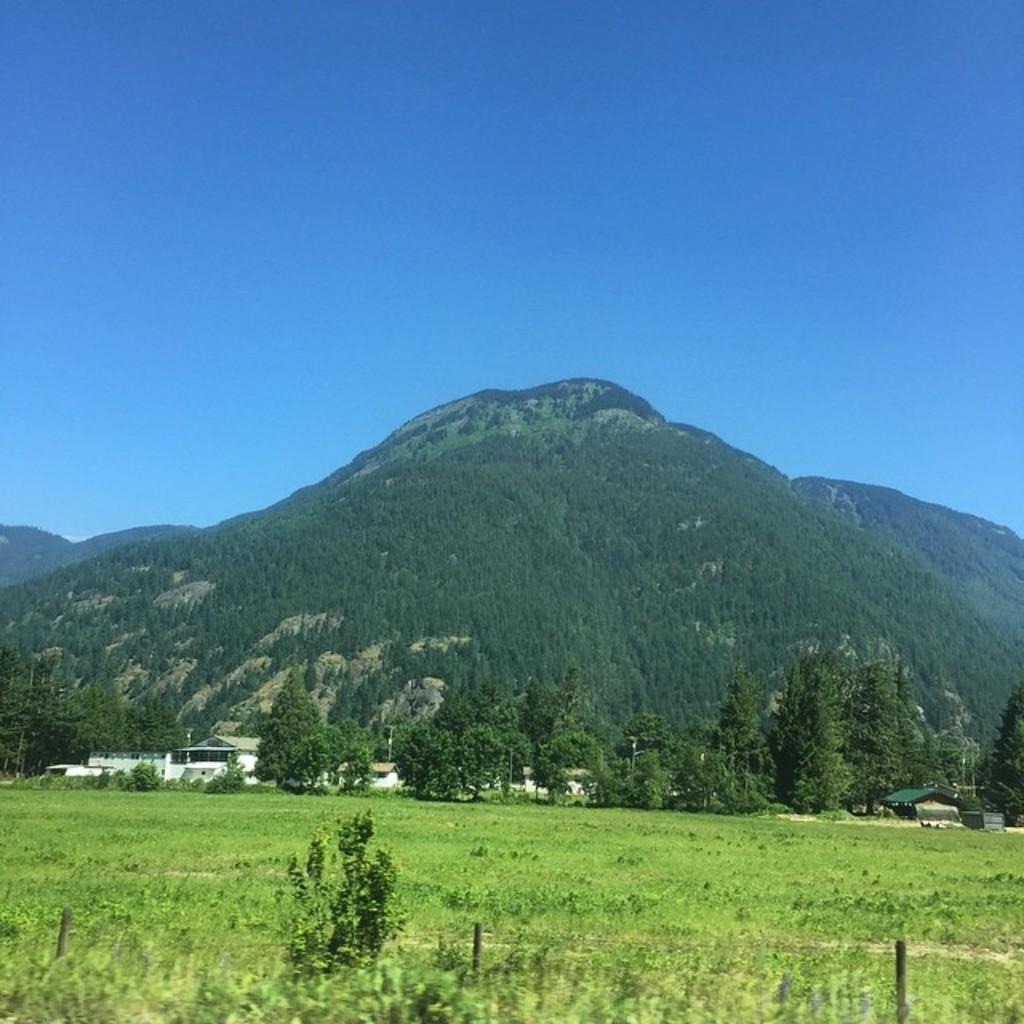Could you give a brief overview of what you see in this image? In this picture I can observe grass and trees on the land. In the background there are hills and sky. 